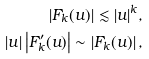<formula> <loc_0><loc_0><loc_500><loc_500>\left | F _ { k } ( u ) \right | \lesssim | u | ^ { k } , \\ | u | \left | F _ { k } ^ { \prime } ( u ) \right | \sim \left | F _ { k } ( u ) \right | ,</formula> 